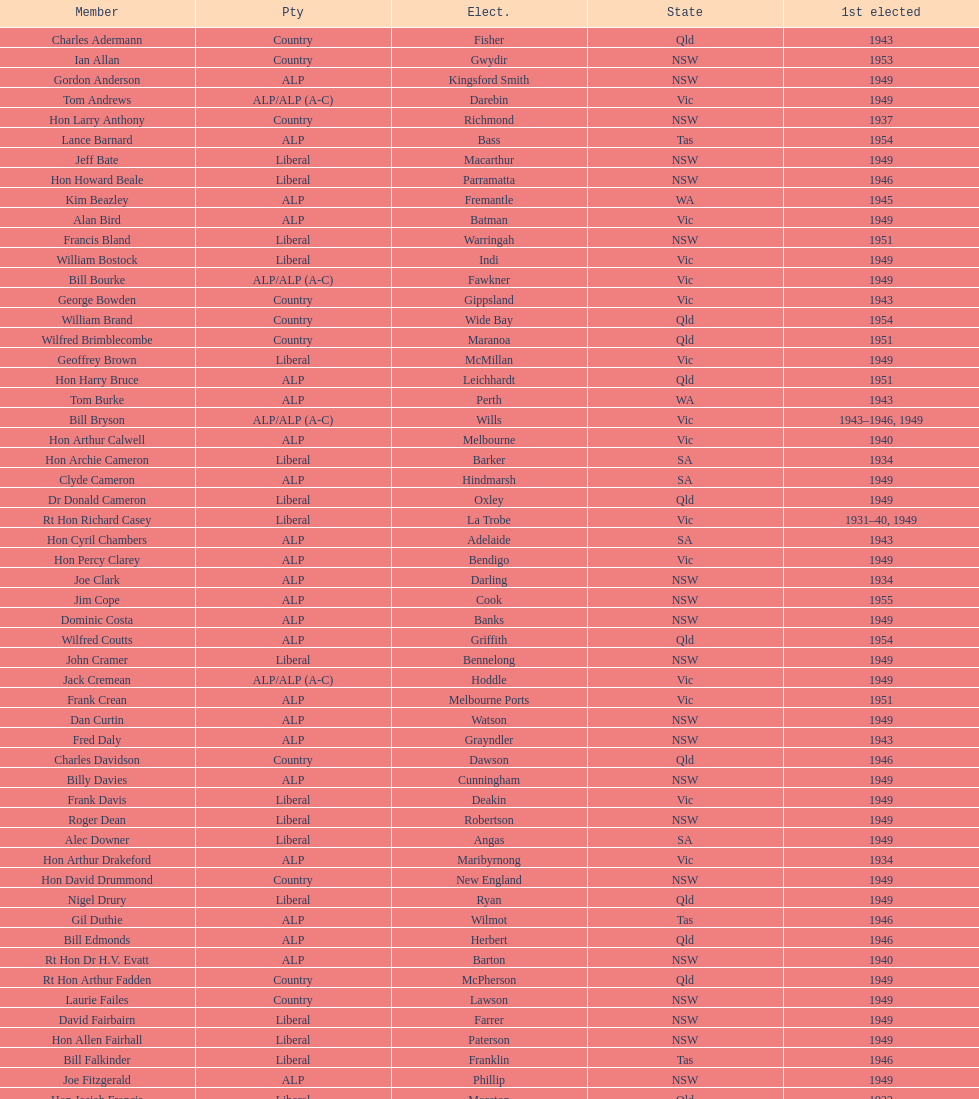After tom burke was elected, what was the next year where another tom would be elected? 1937. 